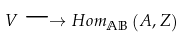Convert formula to latex. <formula><loc_0><loc_0><loc_500><loc_500>V \longrightarrow H o m _ { \mathbb { A B } } \left ( A , Z \right )</formula> 